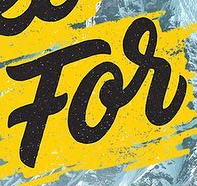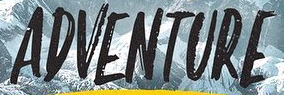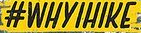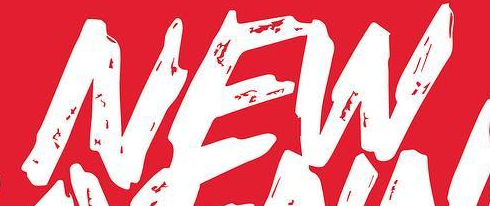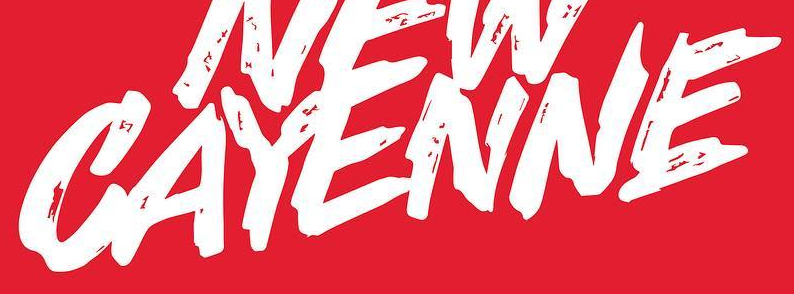Transcribe the words shown in these images in order, separated by a semicolon. For; ADVENTURE; #WHYIHIKE; NEW; CAYENNE 